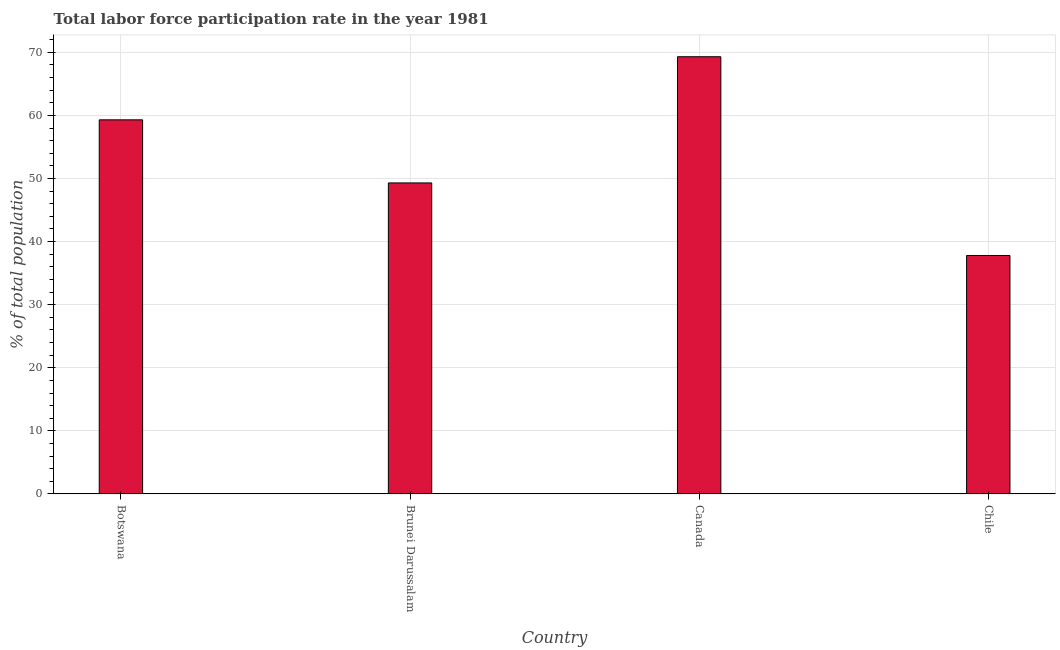Does the graph contain grids?
Ensure brevity in your answer.  Yes. What is the title of the graph?
Ensure brevity in your answer.  Total labor force participation rate in the year 1981. What is the label or title of the Y-axis?
Ensure brevity in your answer.  % of total population. What is the total labor force participation rate in Botswana?
Keep it short and to the point. 59.3. Across all countries, what is the maximum total labor force participation rate?
Offer a very short reply. 69.3. Across all countries, what is the minimum total labor force participation rate?
Provide a succinct answer. 37.8. In which country was the total labor force participation rate minimum?
Provide a short and direct response. Chile. What is the sum of the total labor force participation rate?
Your response must be concise. 215.7. What is the average total labor force participation rate per country?
Give a very brief answer. 53.92. What is the median total labor force participation rate?
Keep it short and to the point. 54.3. In how many countries, is the total labor force participation rate greater than 52 %?
Your answer should be compact. 2. What is the ratio of the total labor force participation rate in Brunei Darussalam to that in Canada?
Keep it short and to the point. 0.71. Is the total labor force participation rate in Brunei Darussalam less than that in Chile?
Give a very brief answer. No. Is the difference between the total labor force participation rate in Brunei Darussalam and Canada greater than the difference between any two countries?
Provide a succinct answer. No. What is the difference between the highest and the second highest total labor force participation rate?
Provide a short and direct response. 10. What is the difference between the highest and the lowest total labor force participation rate?
Offer a terse response. 31.5. In how many countries, is the total labor force participation rate greater than the average total labor force participation rate taken over all countries?
Give a very brief answer. 2. How many bars are there?
Provide a succinct answer. 4. Are all the bars in the graph horizontal?
Your answer should be very brief. No. How many countries are there in the graph?
Provide a short and direct response. 4. What is the difference between two consecutive major ticks on the Y-axis?
Your answer should be very brief. 10. Are the values on the major ticks of Y-axis written in scientific E-notation?
Give a very brief answer. No. What is the % of total population of Botswana?
Keep it short and to the point. 59.3. What is the % of total population in Brunei Darussalam?
Ensure brevity in your answer.  49.3. What is the % of total population in Canada?
Provide a short and direct response. 69.3. What is the % of total population of Chile?
Make the answer very short. 37.8. What is the difference between the % of total population in Botswana and Brunei Darussalam?
Offer a terse response. 10. What is the difference between the % of total population in Botswana and Canada?
Provide a short and direct response. -10. What is the difference between the % of total population in Botswana and Chile?
Provide a succinct answer. 21.5. What is the difference between the % of total population in Brunei Darussalam and Canada?
Make the answer very short. -20. What is the difference between the % of total population in Brunei Darussalam and Chile?
Your answer should be compact. 11.5. What is the difference between the % of total population in Canada and Chile?
Give a very brief answer. 31.5. What is the ratio of the % of total population in Botswana to that in Brunei Darussalam?
Keep it short and to the point. 1.2. What is the ratio of the % of total population in Botswana to that in Canada?
Keep it short and to the point. 0.86. What is the ratio of the % of total population in Botswana to that in Chile?
Your answer should be very brief. 1.57. What is the ratio of the % of total population in Brunei Darussalam to that in Canada?
Make the answer very short. 0.71. What is the ratio of the % of total population in Brunei Darussalam to that in Chile?
Your answer should be compact. 1.3. What is the ratio of the % of total population in Canada to that in Chile?
Keep it short and to the point. 1.83. 